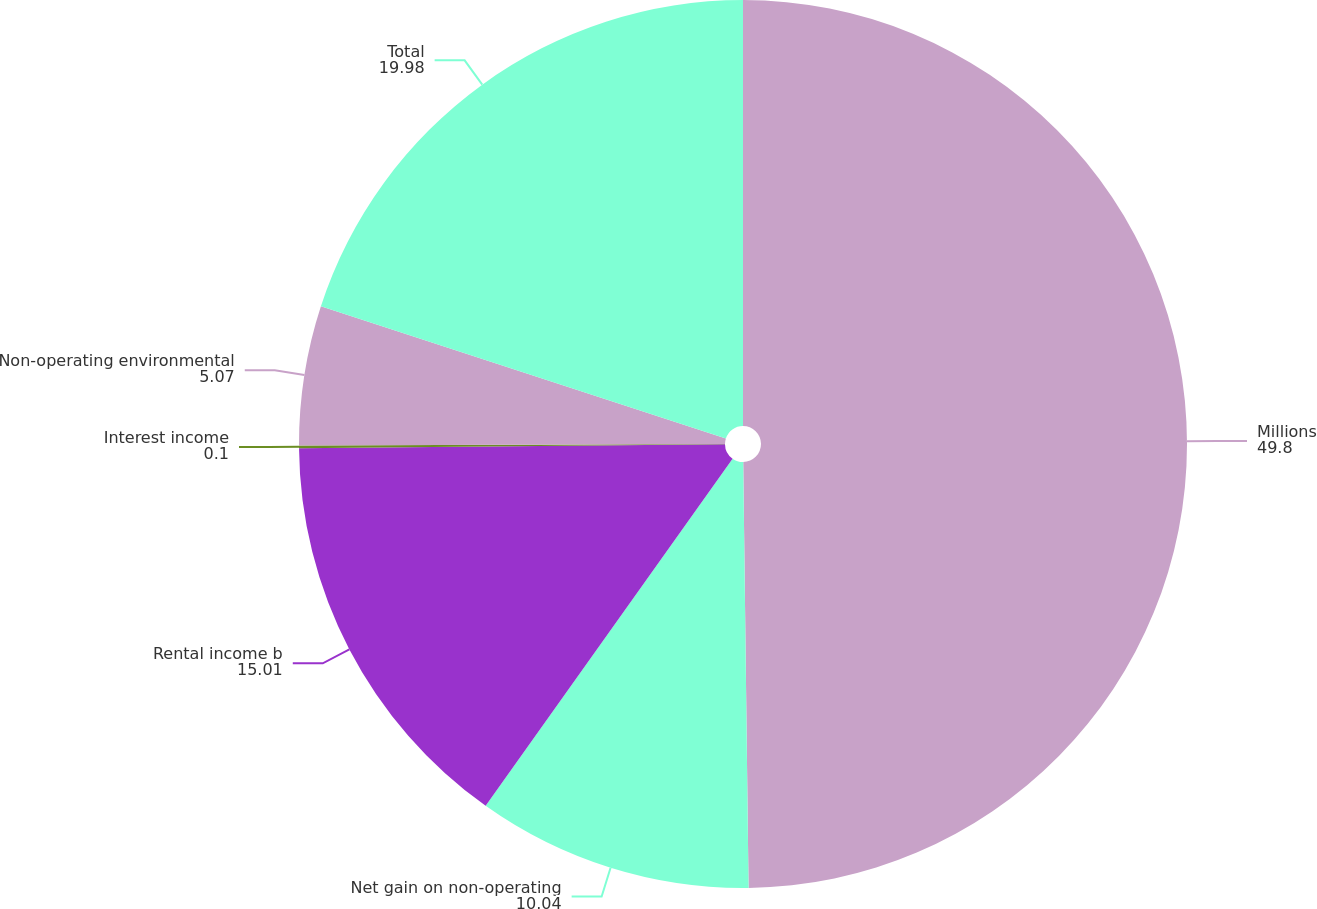Convert chart. <chart><loc_0><loc_0><loc_500><loc_500><pie_chart><fcel>Millions<fcel>Net gain on non-operating<fcel>Rental income b<fcel>Interest income<fcel>Non-operating environmental<fcel>Total<nl><fcel>49.8%<fcel>10.04%<fcel>15.01%<fcel>0.1%<fcel>5.07%<fcel>19.98%<nl></chart> 